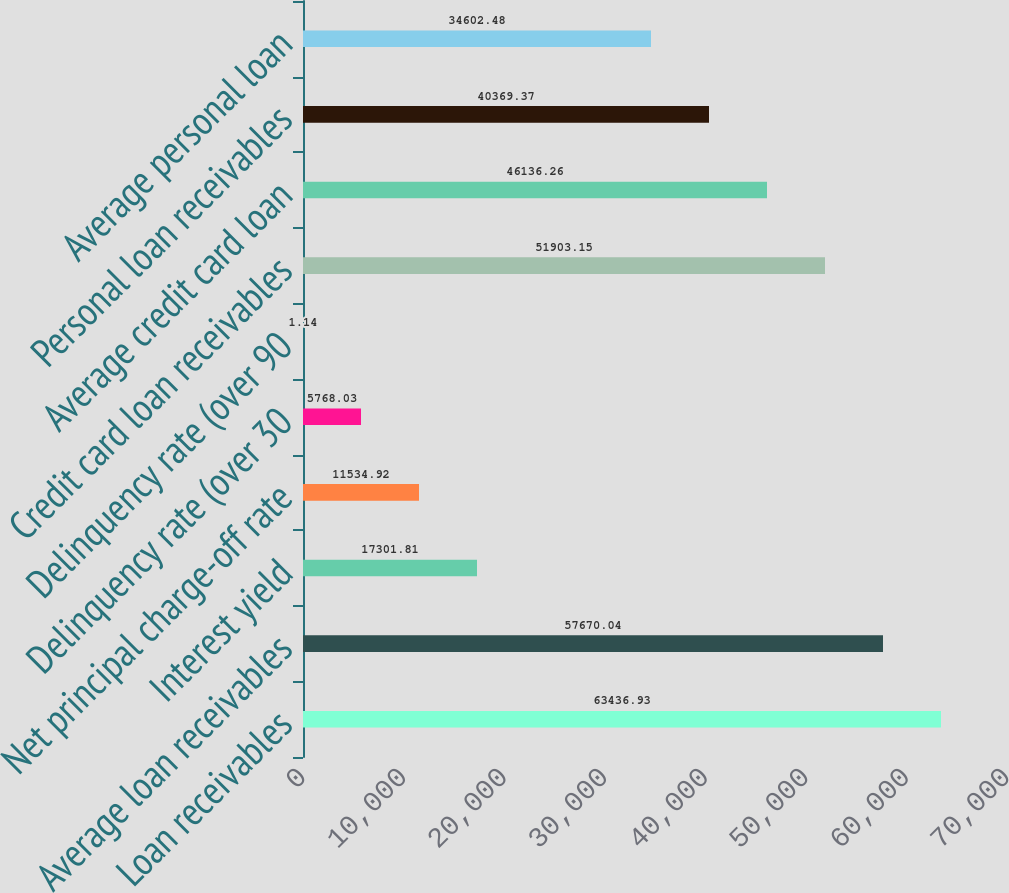Convert chart. <chart><loc_0><loc_0><loc_500><loc_500><bar_chart><fcel>Loan receivables<fcel>Average loan receivables<fcel>Interest yield<fcel>Net principal charge-off rate<fcel>Delinquency rate (over 30<fcel>Delinquency rate (over 90<fcel>Credit card loan receivables<fcel>Average credit card loan<fcel>Personal loan receivables<fcel>Average personal loan<nl><fcel>63436.9<fcel>57670<fcel>17301.8<fcel>11534.9<fcel>5768.03<fcel>1.14<fcel>51903.2<fcel>46136.3<fcel>40369.4<fcel>34602.5<nl></chart> 